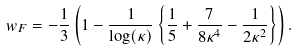<formula> <loc_0><loc_0><loc_500><loc_500>w _ { F } = - \frac { 1 } { 3 } \left ( 1 - \frac { 1 } { \log ( \kappa ) } \left \{ \frac { 1 } { 5 } + \frac { 7 } { 8 \kappa ^ { 4 } } - \frac { 1 } { 2 \kappa ^ { 2 } } \right \} \right ) .</formula> 